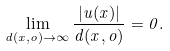<formula> <loc_0><loc_0><loc_500><loc_500>\lim _ { d ( x , o ) \to \infty } \frac { | u ( x ) | } { d ( x , o ) } = 0 .</formula> 